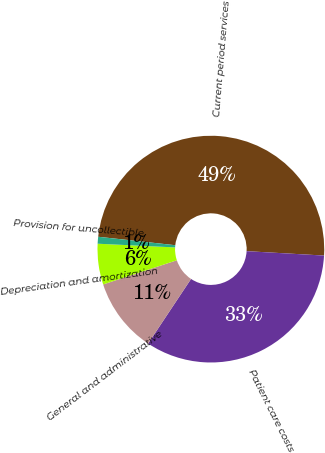Convert chart. <chart><loc_0><loc_0><loc_500><loc_500><pie_chart><fcel>Current period services<fcel>Patient care costs<fcel>General and administrative<fcel>Depreciation and amortization<fcel>Provision for uncollectible<nl><fcel>49.16%<fcel>33.43%<fcel>10.62%<fcel>5.8%<fcel>0.98%<nl></chart> 